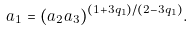Convert formula to latex. <formula><loc_0><loc_0><loc_500><loc_500>a _ { 1 } = ( a _ { 2 } a _ { 3 } ) ^ { ( 1 + 3 q _ { 1 } ) / ( 2 - 3 q _ { 1 } ) } .</formula> 